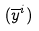<formula> <loc_0><loc_0><loc_500><loc_500>( \overline { y } ^ { i } )</formula> 